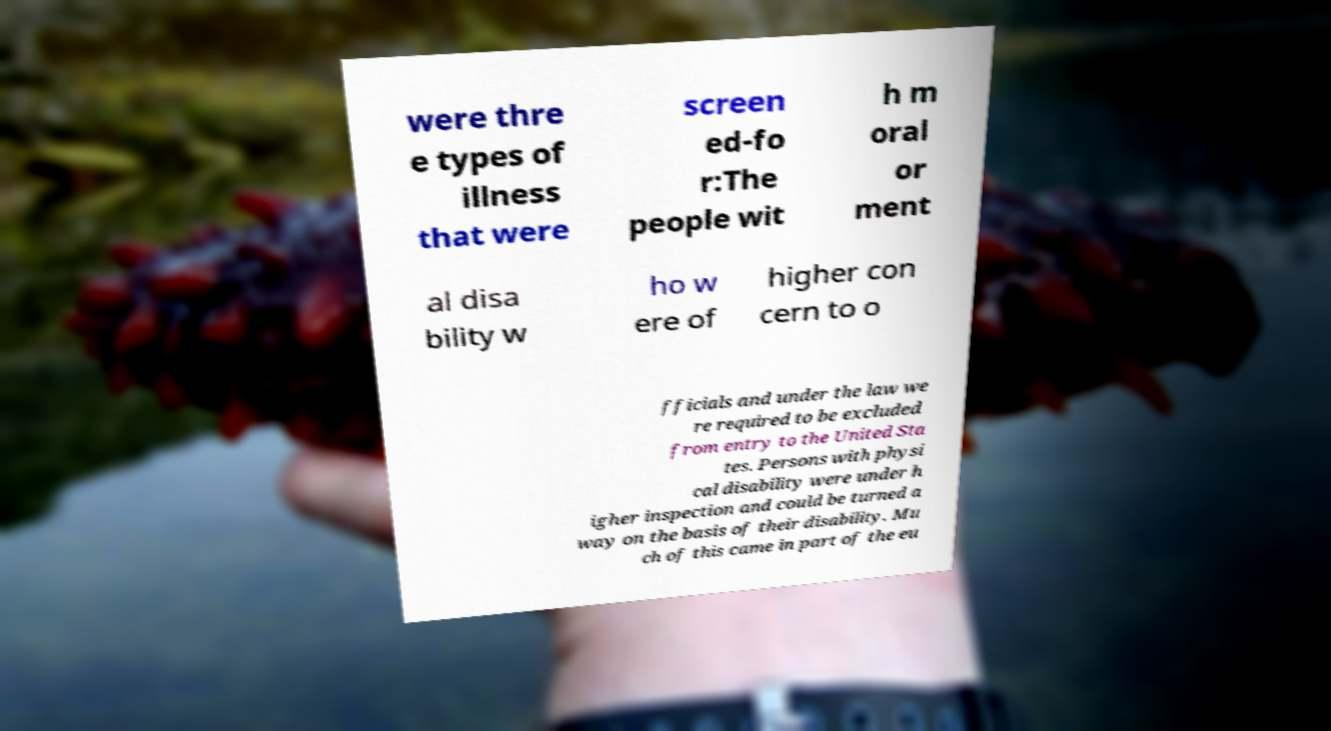I need the written content from this picture converted into text. Can you do that? were thre e types of illness that were screen ed-fo r:The people wit h m oral or ment al disa bility w ho w ere of higher con cern to o fficials and under the law we re required to be excluded from entry to the United Sta tes. Persons with physi cal disability were under h igher inspection and could be turned a way on the basis of their disability. Mu ch of this came in part of the eu 